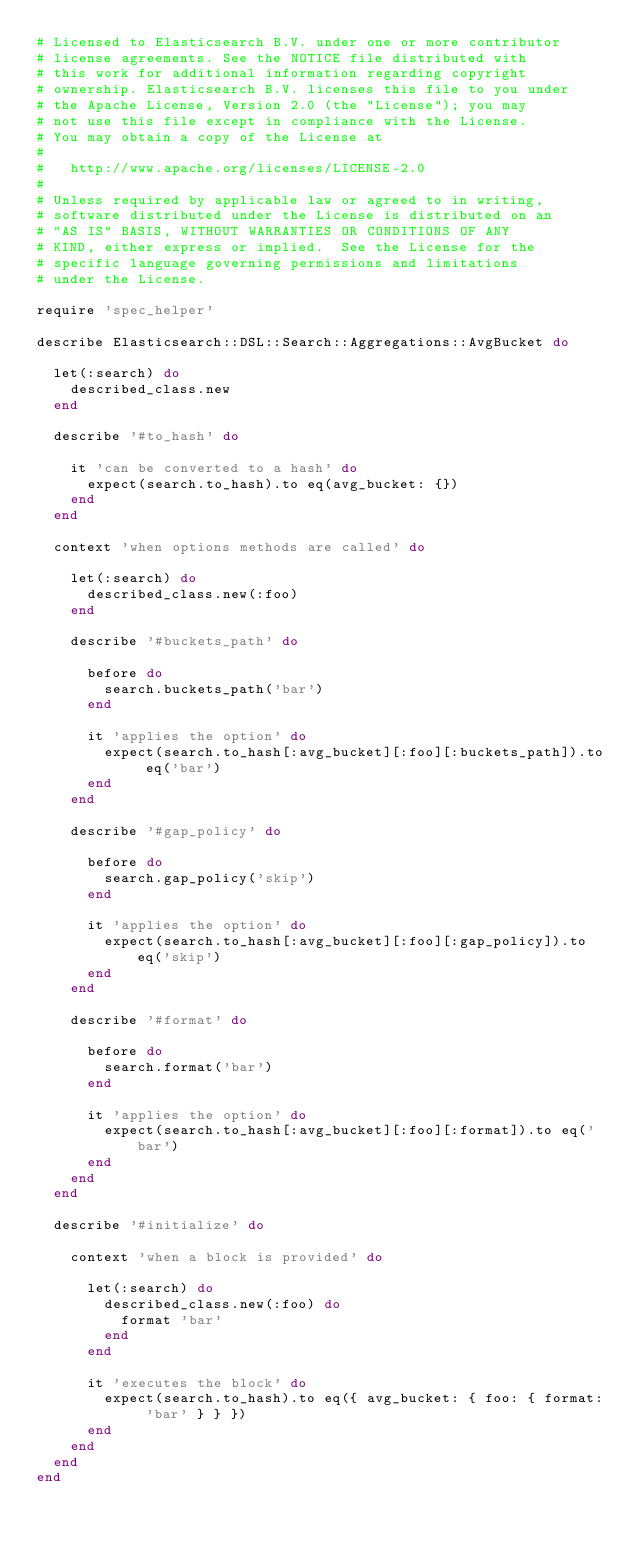<code> <loc_0><loc_0><loc_500><loc_500><_Ruby_># Licensed to Elasticsearch B.V. under one or more contributor
# license agreements. See the NOTICE file distributed with
# this work for additional information regarding copyright
# ownership. Elasticsearch B.V. licenses this file to you under
# the Apache License, Version 2.0 (the "License"); you may
# not use this file except in compliance with the License.
# You may obtain a copy of the License at
#
#   http://www.apache.org/licenses/LICENSE-2.0
#
# Unless required by applicable law or agreed to in writing,
# software distributed under the License is distributed on an
# "AS IS" BASIS, WITHOUT WARRANTIES OR CONDITIONS OF ANY
# KIND, either express or implied.  See the License for the
# specific language governing permissions and limitations
# under the License.

require 'spec_helper'

describe Elasticsearch::DSL::Search::Aggregations::AvgBucket do

  let(:search) do
    described_class.new
  end

  describe '#to_hash' do

    it 'can be converted to a hash' do
      expect(search.to_hash).to eq(avg_bucket: {})
    end
  end

  context 'when options methods are called' do

    let(:search) do
      described_class.new(:foo)
    end

    describe '#buckets_path' do

      before do
        search.buckets_path('bar')
      end

      it 'applies the option' do
        expect(search.to_hash[:avg_bucket][:foo][:buckets_path]).to eq('bar')
      end
    end

    describe '#gap_policy' do

      before do
        search.gap_policy('skip')
      end

      it 'applies the option' do
        expect(search.to_hash[:avg_bucket][:foo][:gap_policy]).to eq('skip')
      end
    end

    describe '#format' do

      before do
        search.format('bar')
      end

      it 'applies the option' do
        expect(search.to_hash[:avg_bucket][:foo][:format]).to eq('bar')
      end
    end
  end

  describe '#initialize' do

    context 'when a block is provided' do

      let(:search) do
        described_class.new(:foo) do
          format 'bar'
        end
      end

      it 'executes the block' do
        expect(search.to_hash).to eq({ avg_bucket: { foo: { format: 'bar' } } })
      end
    end
  end
end
</code> 